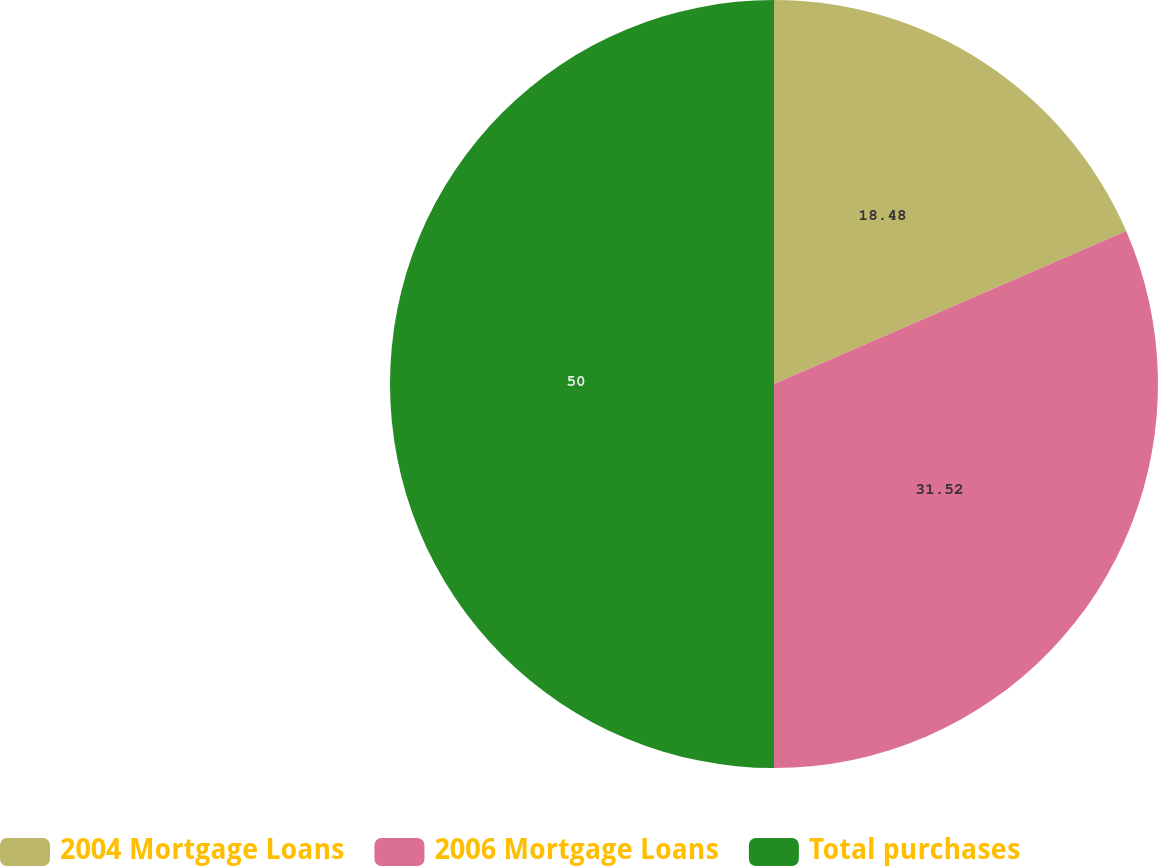Convert chart to OTSL. <chart><loc_0><loc_0><loc_500><loc_500><pie_chart><fcel>2004 Mortgage Loans<fcel>2006 Mortgage Loans<fcel>Total purchases<nl><fcel>18.48%<fcel>31.52%<fcel>50.0%<nl></chart> 